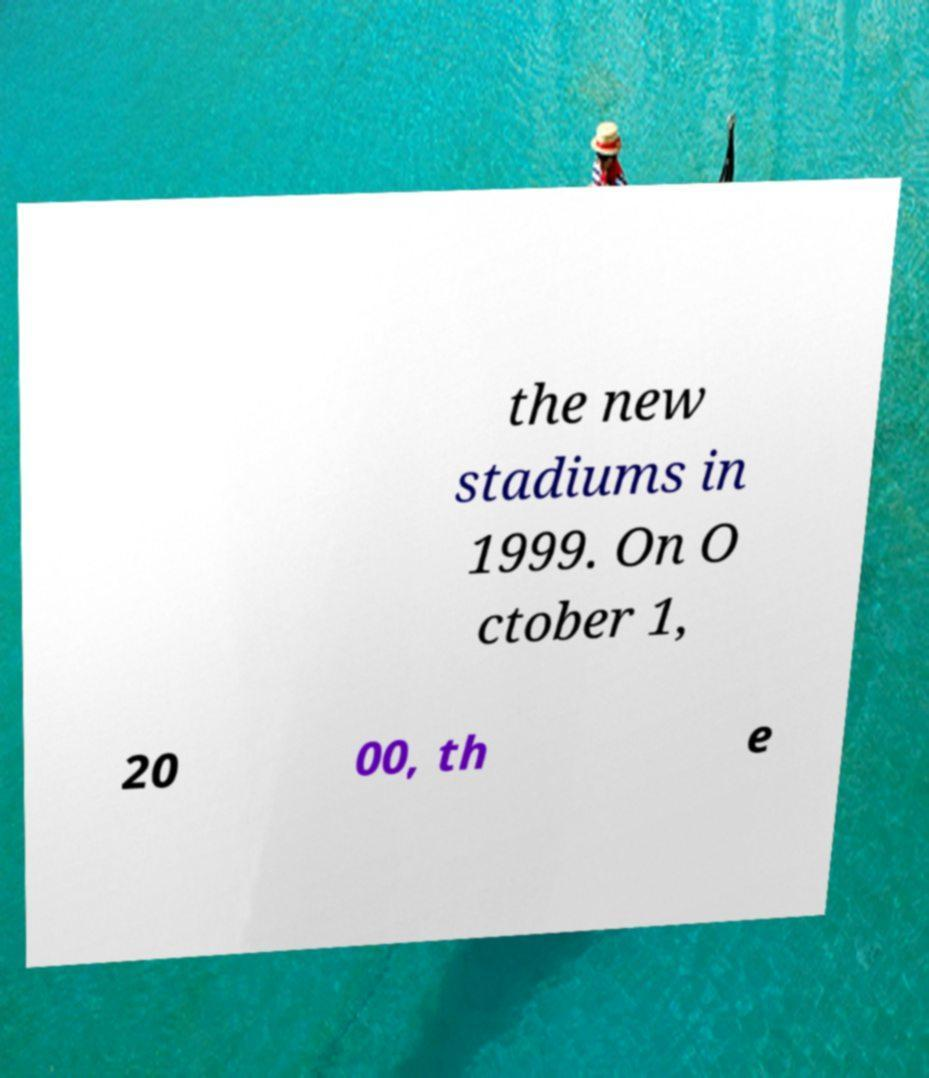Can you accurately transcribe the text from the provided image for me? the new stadiums in 1999. On O ctober 1, 20 00, th e 